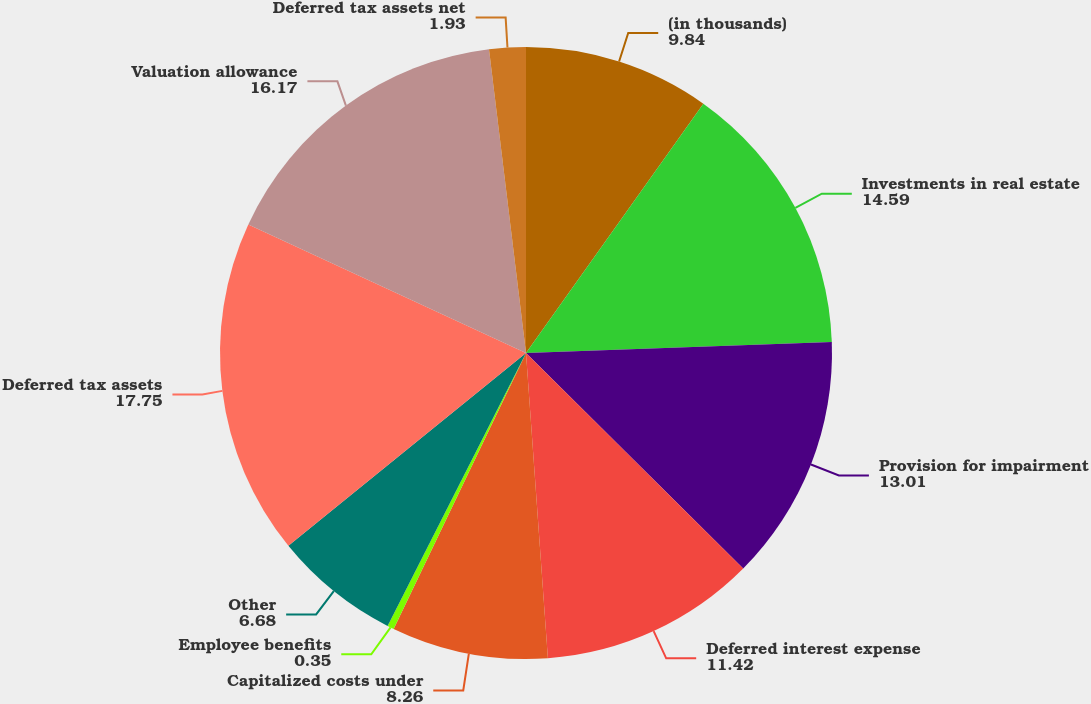Convert chart. <chart><loc_0><loc_0><loc_500><loc_500><pie_chart><fcel>(in thousands)<fcel>Investments in real estate<fcel>Provision for impairment<fcel>Deferred interest expense<fcel>Capitalized costs under<fcel>Employee benefits<fcel>Other<fcel>Deferred tax assets<fcel>Valuation allowance<fcel>Deferred tax assets net<nl><fcel>9.84%<fcel>14.59%<fcel>13.01%<fcel>11.42%<fcel>8.26%<fcel>0.35%<fcel>6.68%<fcel>17.75%<fcel>16.17%<fcel>1.93%<nl></chart> 